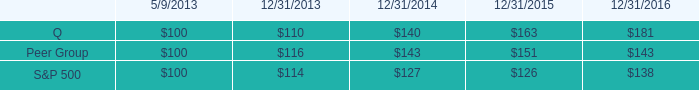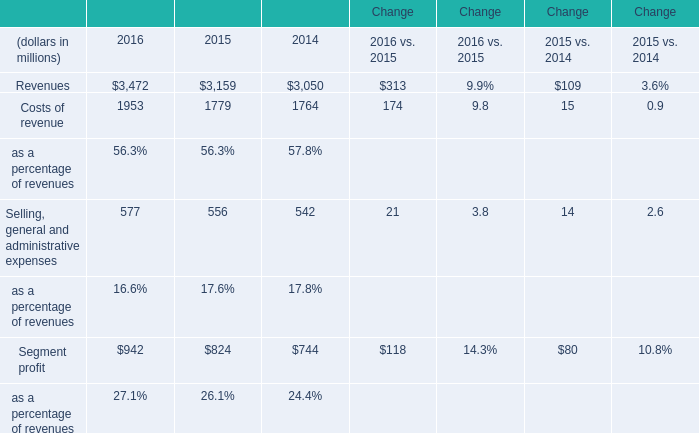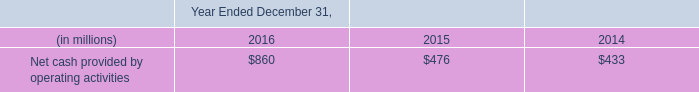in 2013 what was the anticipated percentage growth in the stock performance for the peer group in 2014 
Computations: ((143 - 100) / 100)
Answer: 0.43. 